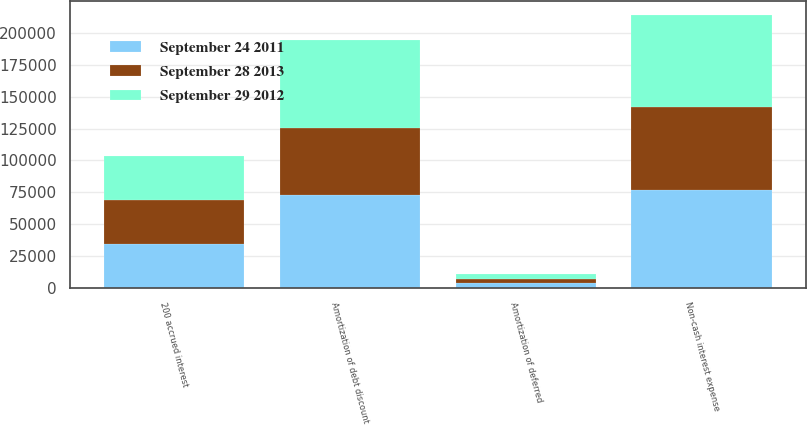Convert chart to OTSL. <chart><loc_0><loc_0><loc_500><loc_500><stacked_bar_chart><ecel><fcel>Amortization of debt discount<fcel>Amortization of deferred<fcel>Non-cash interest expense<fcel>200 accrued interest<nl><fcel>September 28 2013<fcel>52732<fcel>3048<fcel>65005<fcel>34376<nl><fcel>September 29 2012<fcel>68532<fcel>3828<fcel>72360<fcel>34898<nl><fcel>September 24 2011<fcel>72908<fcel>3906<fcel>76814<fcel>34427<nl></chart> 